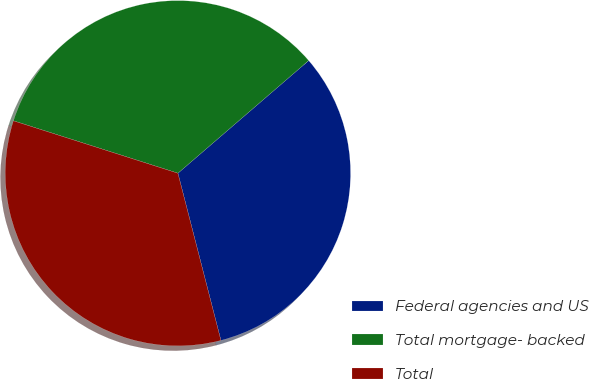<chart> <loc_0><loc_0><loc_500><loc_500><pie_chart><fcel>Federal agencies and US<fcel>Total mortgage- backed<fcel>Total<nl><fcel>32.31%<fcel>33.77%<fcel>33.92%<nl></chart> 